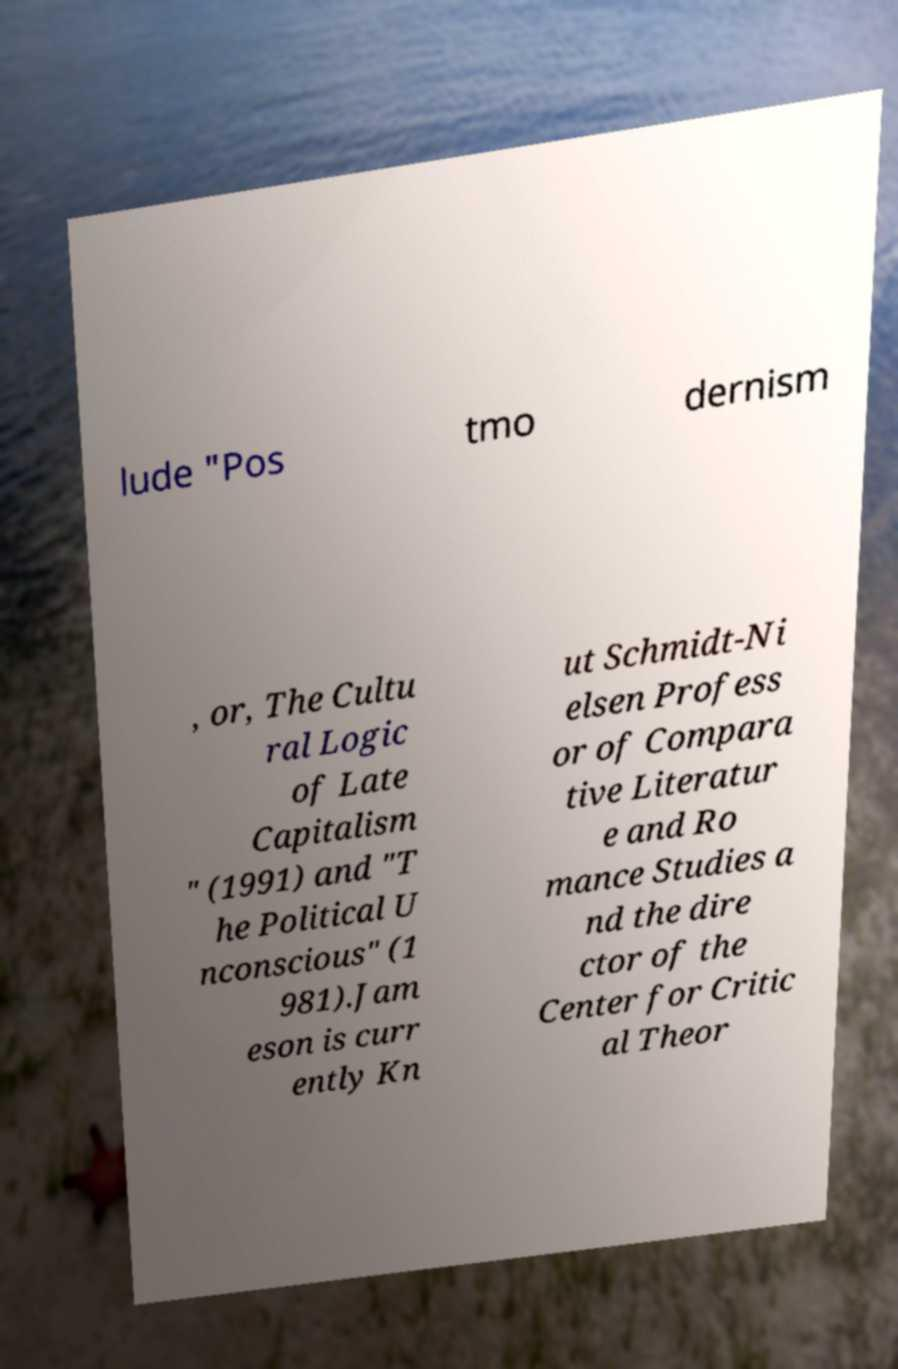Can you accurately transcribe the text from the provided image for me? lude "Pos tmo dernism , or, The Cultu ral Logic of Late Capitalism " (1991) and "T he Political U nconscious" (1 981).Jam eson is curr ently Kn ut Schmidt-Ni elsen Profess or of Compara tive Literatur e and Ro mance Studies a nd the dire ctor of the Center for Critic al Theor 